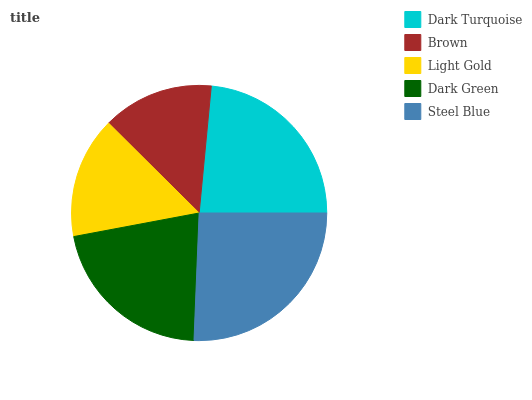Is Brown the minimum?
Answer yes or no. Yes. Is Steel Blue the maximum?
Answer yes or no. Yes. Is Light Gold the minimum?
Answer yes or no. No. Is Light Gold the maximum?
Answer yes or no. No. Is Light Gold greater than Brown?
Answer yes or no. Yes. Is Brown less than Light Gold?
Answer yes or no. Yes. Is Brown greater than Light Gold?
Answer yes or no. No. Is Light Gold less than Brown?
Answer yes or no. No. Is Dark Green the high median?
Answer yes or no. Yes. Is Dark Green the low median?
Answer yes or no. Yes. Is Brown the high median?
Answer yes or no. No. Is Steel Blue the low median?
Answer yes or no. No. 